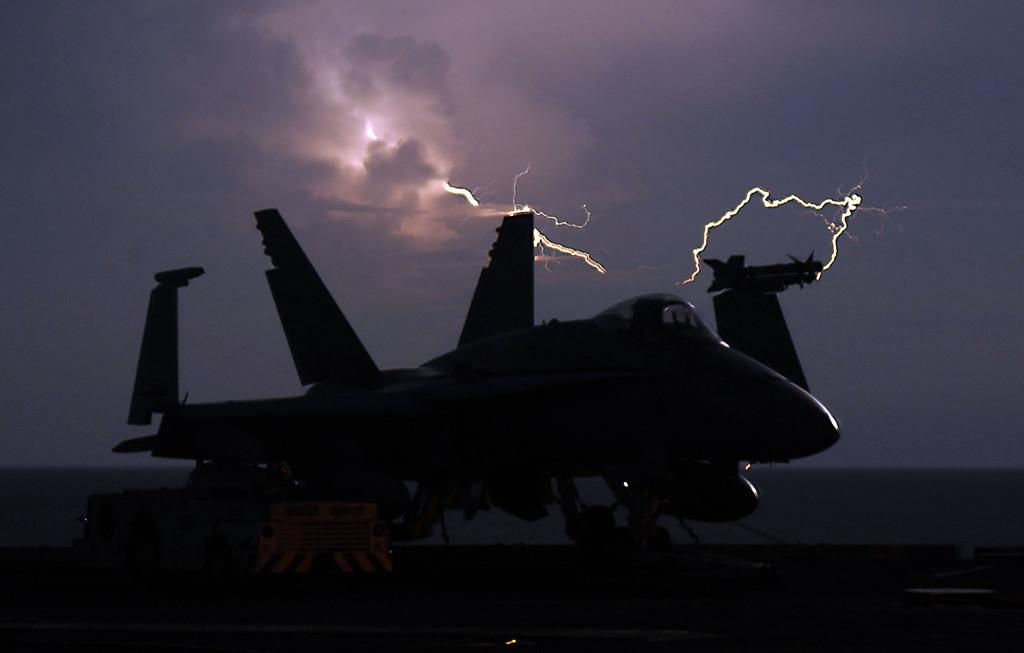What is the lighting condition in the image? The image was taken in the dark. What can be seen on the land in the image? There is a plane on the land in the image. What is visible in the sky in the background of the image? There are thunders visible in the sky in the background of the image. What type of butter is being used to grease the shoes in the image? There is no butter or shoes present in the image. 